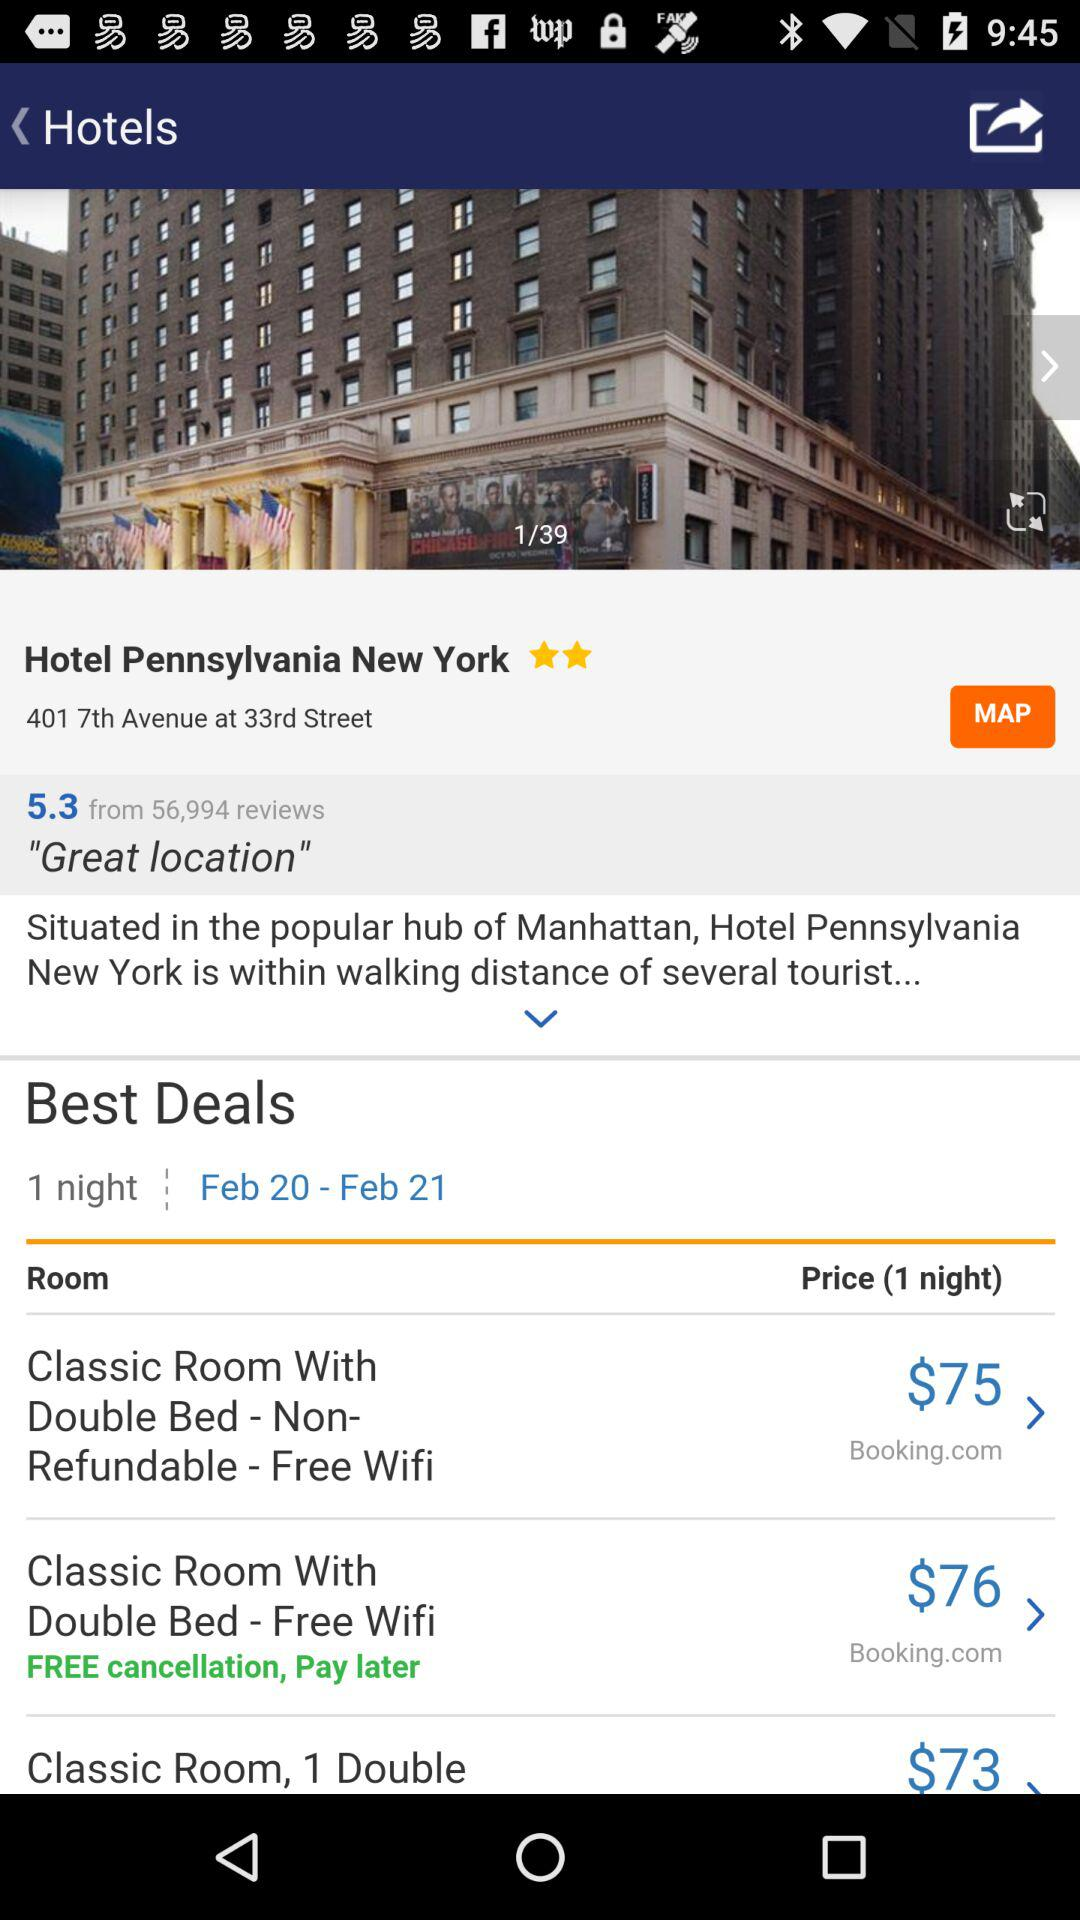How many people gave reviews for Hotel Pennsylvania New York? The number of people who gave reviews is 56,994. 